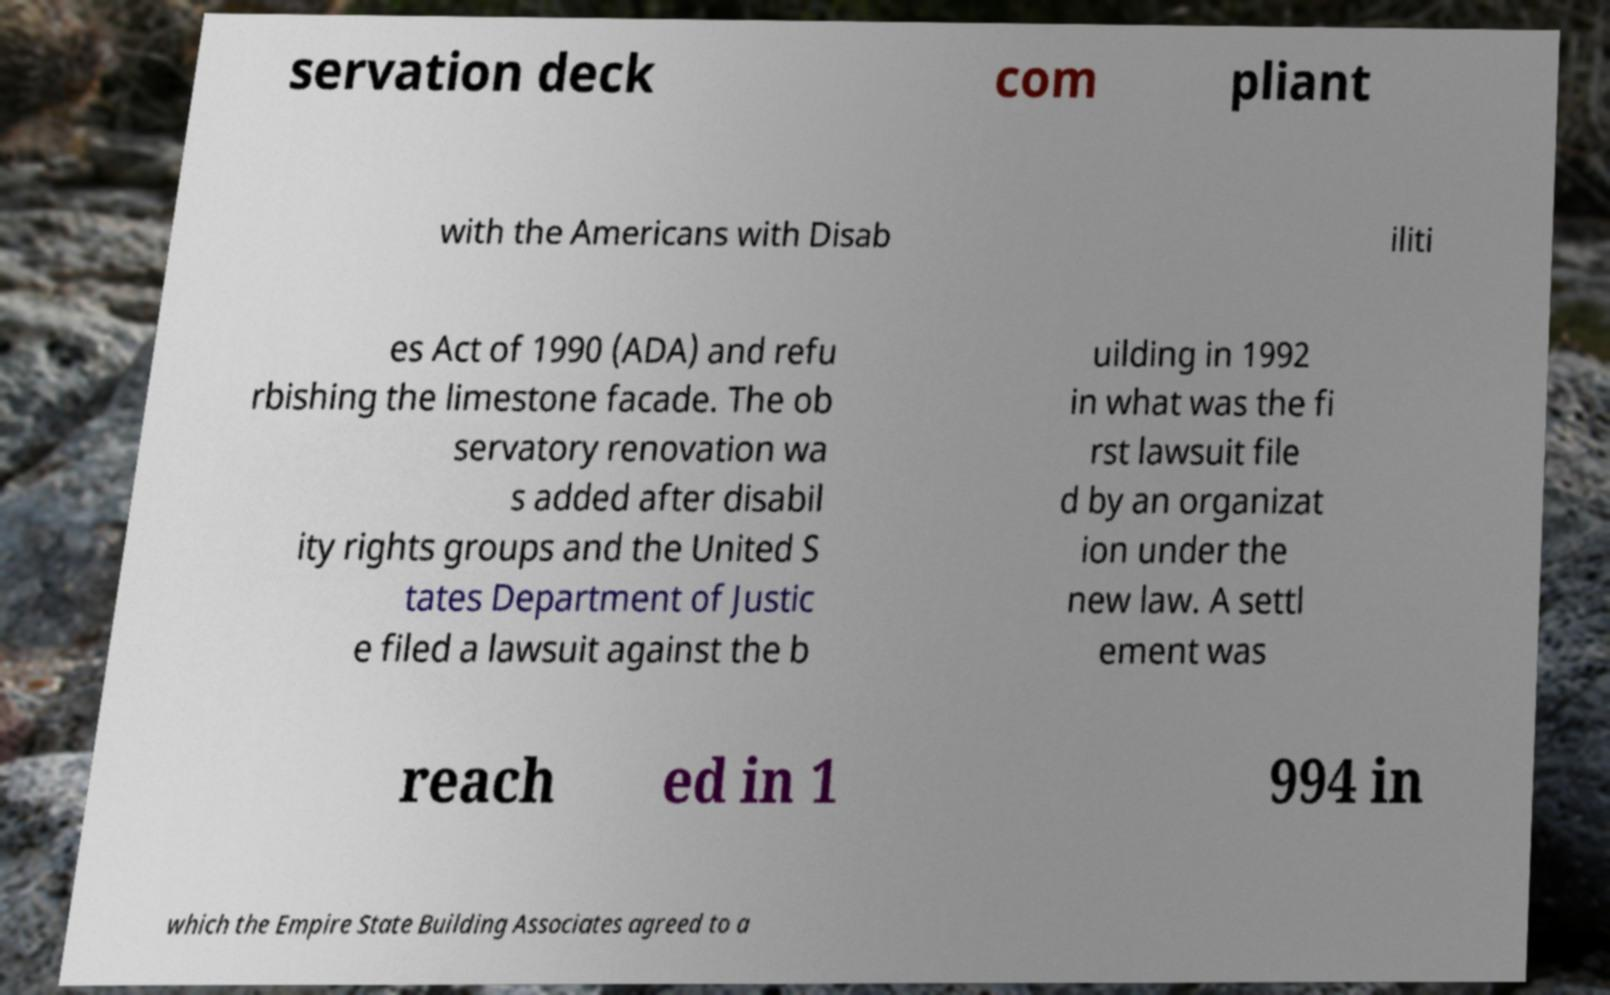Can you read and provide the text displayed in the image?This photo seems to have some interesting text. Can you extract and type it out for me? servation deck com pliant with the Americans with Disab iliti es Act of 1990 (ADA) and refu rbishing the limestone facade. The ob servatory renovation wa s added after disabil ity rights groups and the United S tates Department of Justic e filed a lawsuit against the b uilding in 1992 in what was the fi rst lawsuit file d by an organizat ion under the new law. A settl ement was reach ed in 1 994 in which the Empire State Building Associates agreed to a 